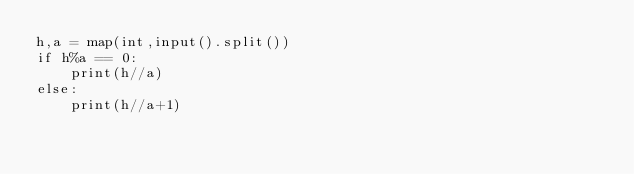Convert code to text. <code><loc_0><loc_0><loc_500><loc_500><_Python_>h,a = map(int,input().split())
if h%a == 0:
    print(h//a)
else:
    print(h//a+1)</code> 